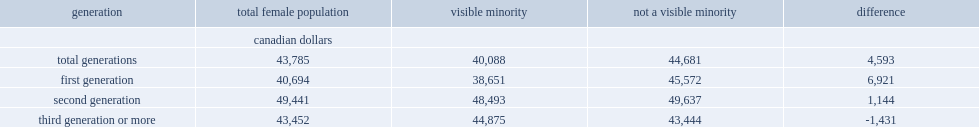Among visible minority women of core working age, what was the median employment income? 40088.0. What was the difference between visible minority women of core working age's median employment income and not a visible minority women? 4593. What was the median income of first-generation visible minority women of core working age in 2011? 38651.0. What was the difference between visible minority women and first-generation women of the same age who did not belong to a visible minority group earned a median income? 6921. What was the employment gap narrowed to among second-generation women? 1144.0. How much did second-generation visible minority women between the ages of 25 and 54 earn a median income? 48493.0. How much did second-generation not a visible minority women between the ages of 25 and 54 earn a median income? 49637.0. 